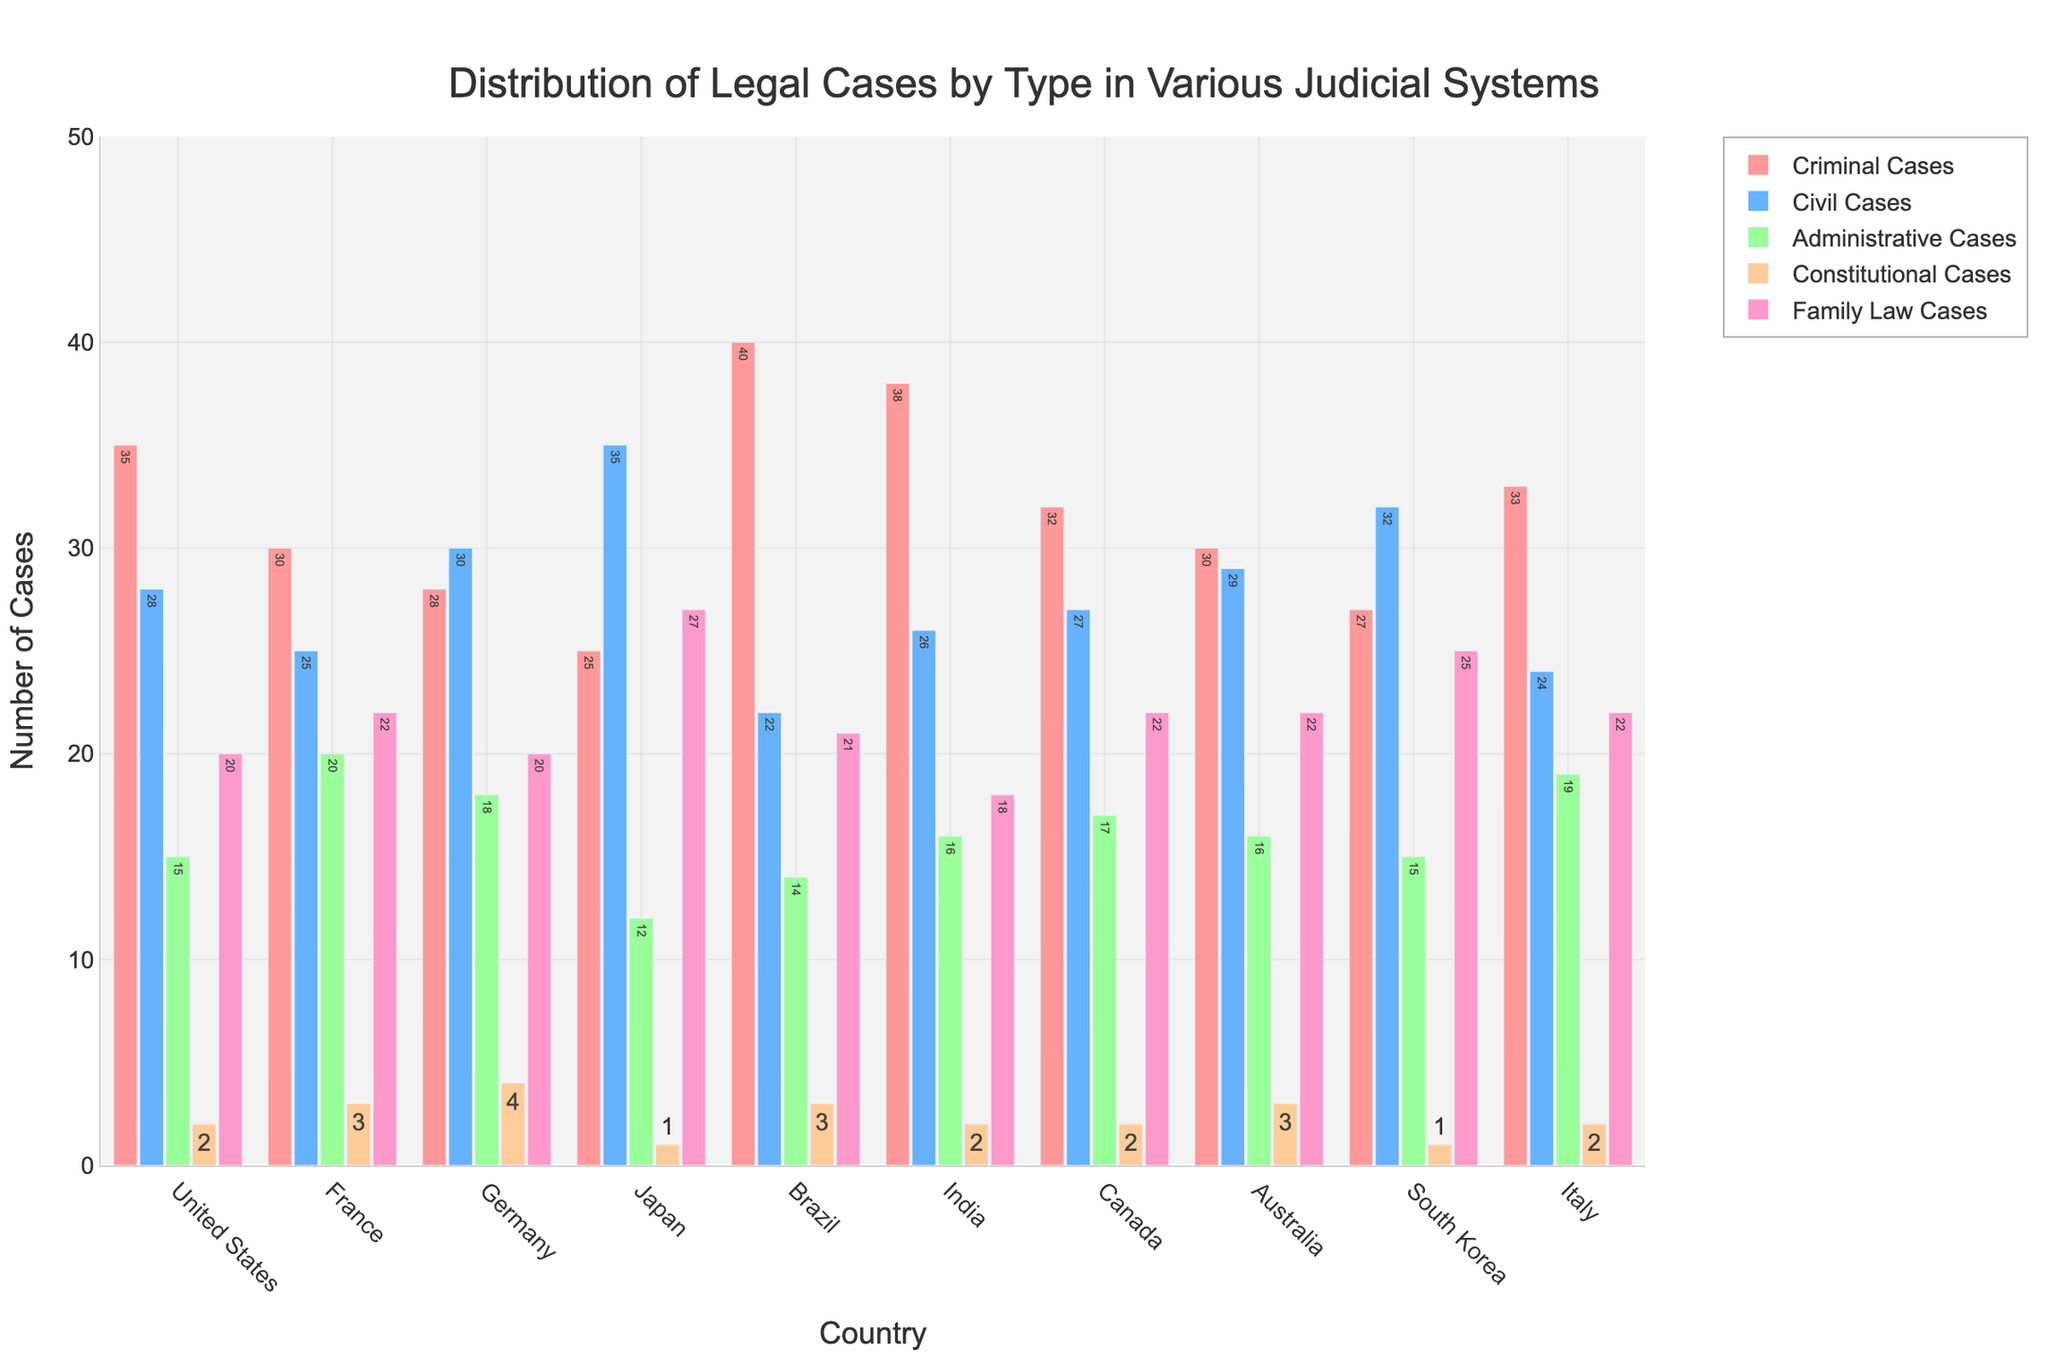What's the country with the highest number of criminal cases? Look at the bars representing criminal cases for each country. The tallest bar indicates the highest number. Brazil has the highest bar in the criminal cases category.
Answer: Brazil Which country has the lowest number of constitutional cases? Examine the bars for constitutional cases. The shortest one represents the lowest number. Both Japan and South Korea have the lowest, with a bar height of 1 case each.
Answer: Japan and South Korea What is the total number of family law cases in Canada and India combined? Add the number of family law cases from Canada and India: 22 (Canada) + 18 (India) = 40.
Answer: 40 Which country has more civil cases, France or Germany? Compare the bars of civil cases for France and Germany. The bar for Germany is taller than the bar for France.
Answer: Germany What's the difference in the number of administrative cases between Italy and South Korea? Subtract the number of administrative cases in South Korea from the number in Italy: 19 (Italy) - 15 (South Korea) = 4.
Answer: 4 How many total cases are there in the United States? Sum all types of cases in the United States: 35 (Criminal) + 28 (Civil) + 15 (Administrative) + 2 (Constitutional) + 20 (Family Law) = 100.
Answer: 100 Which case type is most common in Japan? Look at the highest bar representing case types in Japan. The tallest bar for Japan is for Civil Cases with a count of 35.
Answer: Civil Cases Is the number of constitutional cases in France greater than in Germany? Compare the bars of constitutional cases for France and Germany. France has a bar height of 3 and Germany has a bar height of 4. Thus, Germany has more.
Answer: No What is the average number of criminal cases across all countries? Add the number of criminal cases for all countries and divide by the number of countries: (35 + 30 + 28 + 25 + 40 + 38 + 32 + 30 + 27 + 33) / 10 = 31.8.
Answer: 31.8 Which country has the highest total number of cases across all types? Sum the total cases for each country and compare. Brazil has the highest total of 40 (Criminal) + 22 (Civil) + 14 (Administrative) + 3 (Constitutional) + 21 (Family Law) = 100. Brazil and the United States are tied.
Answer: Brazil and the United States 